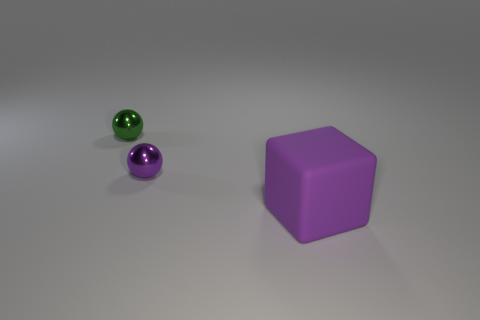Can you tell me more about the lighting in this scene? Sure, the scene is lit in a way that creates soft shadows on the ground, indicating a diffused light source above. The reflections on the objects suggest a single light source, possibly resembling indirect daylight or a softbox in a studio setting. 